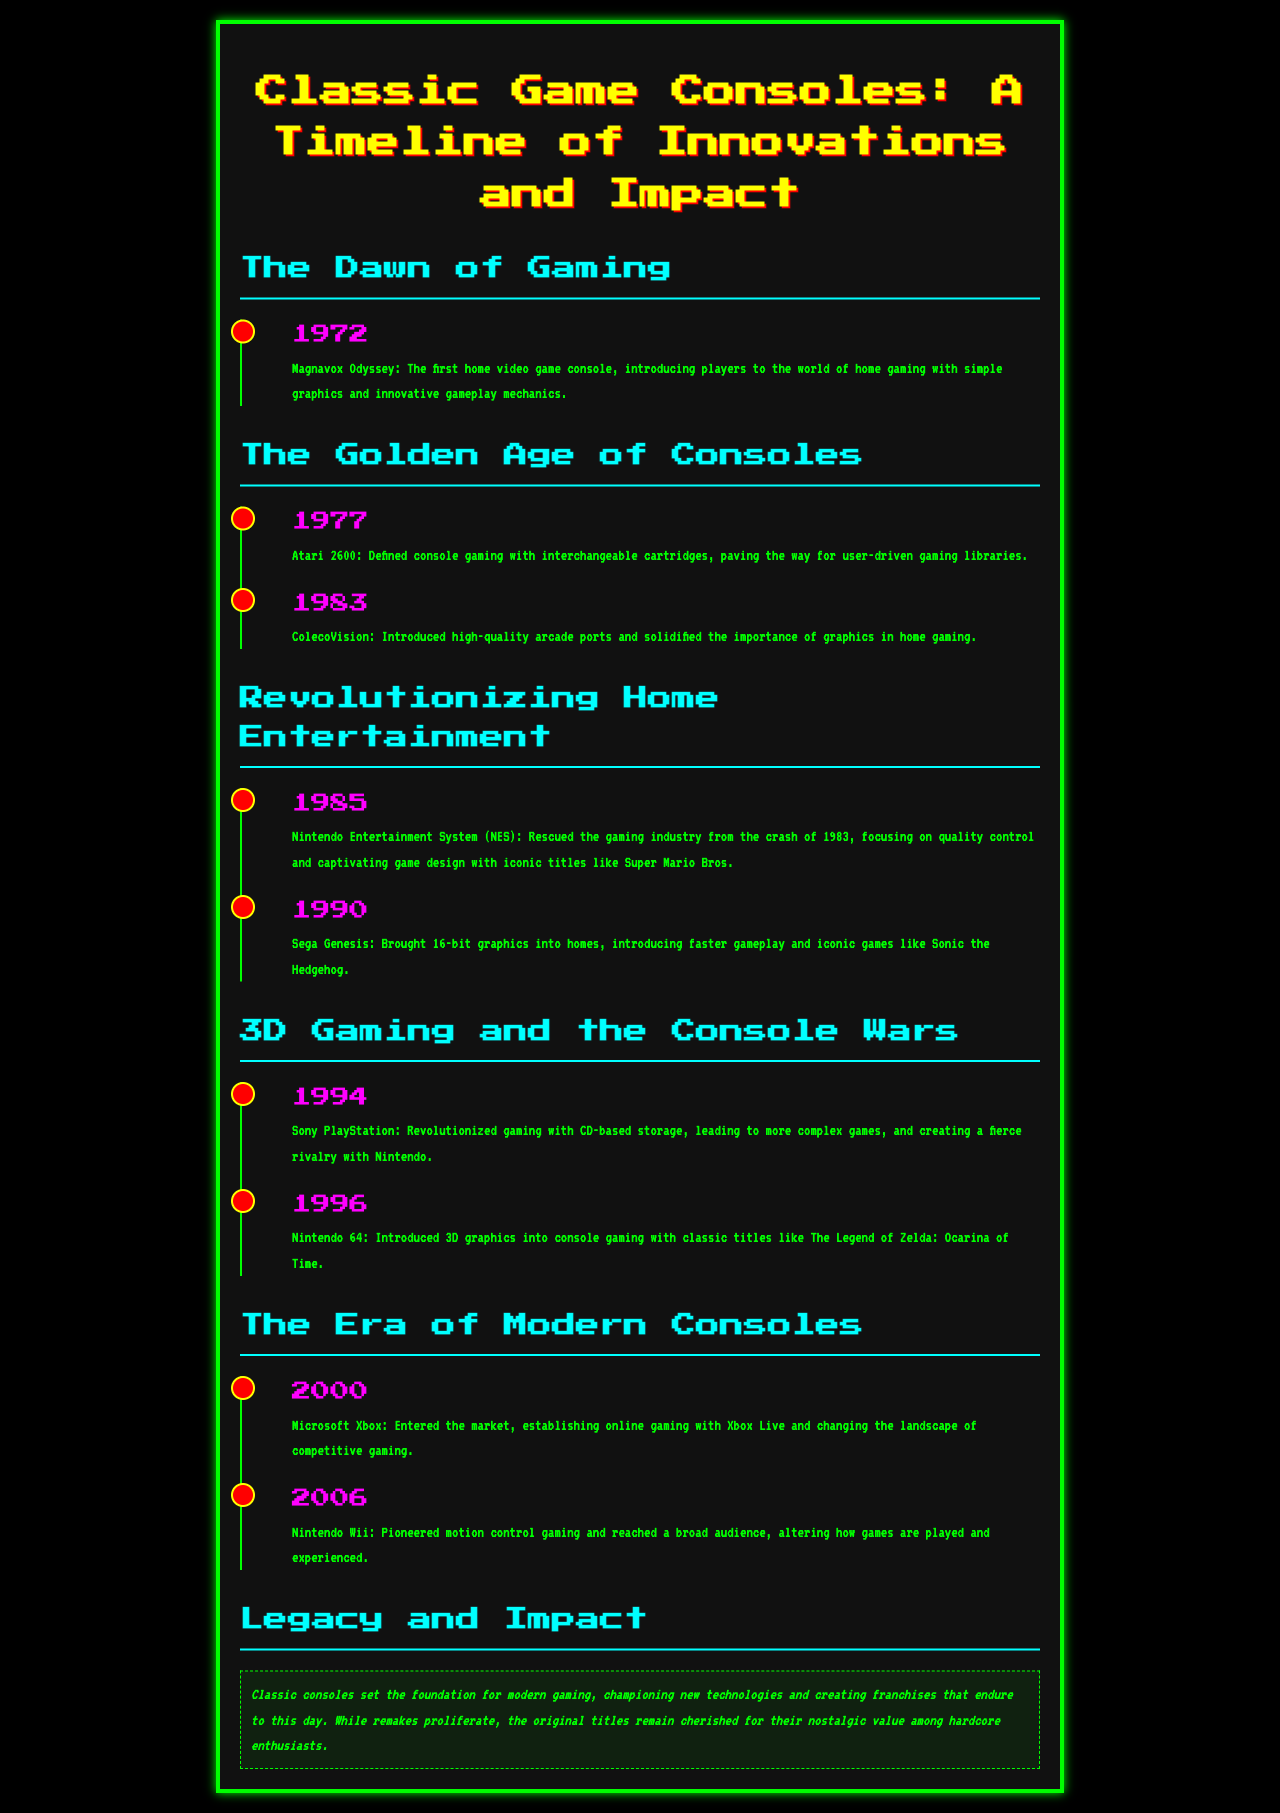what year was the Magnavox Odyssey released? The document states that the Magnavox Odyssey was released in 1972.
Answer: 1972 which console introduced interchangeable cartridges? The Atari 2600 is noted for defining console gaming with interchangeable cartridges.
Answer: Atari 2600 what iconic game did the Nintendo Entertainment System help popularize? The summary for the NES mentions the iconic title Super Mario Bros.
Answer: Super Mario Bros which console changed the landscape of competitive gaming? The Microsoft Xbox is specified as establishing online gaming with Xbox Live.
Answer: Microsoft Xbox what was a key feature of the Nintendo Wii? The document highlights that the Nintendo Wii pioneered motion control gaming.
Answer: motion control gaming which console was released in 1985? The document indicates that the Nintendo Entertainment System was released in 1985.
Answer: Nintendo Entertainment System what major innovation did the Sony PlayStation introduce? The document explains that the Sony PlayStation revolutionized gaming with CD-based storage.
Answer: CD-based storage what was the significance of the Nintendo 64? It is mentioned that the Nintendo 64 introduced 3D graphics into console gaming.
Answer: 3D graphics how does the brochure describe the impact of classic consoles? The summary states that classic consoles set the foundation for modern gaming.
Answer: set the foundation for modern gaming 